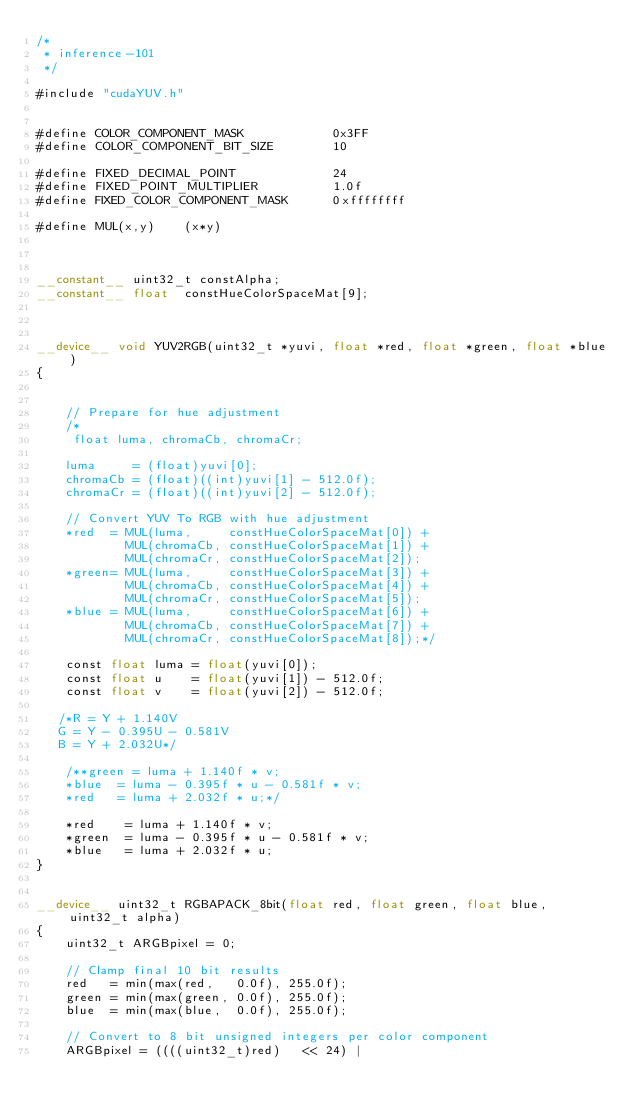<code> <loc_0><loc_0><loc_500><loc_500><_Cuda_>/*
 * inference-101
 */

#include "cudaYUV.h"


#define COLOR_COMPONENT_MASK            0x3FF
#define COLOR_COMPONENT_BIT_SIZE        10

#define FIXED_DECIMAL_POINT             24
#define FIXED_POINT_MULTIPLIER          1.0f
#define FIXED_COLOR_COMPONENT_MASK      0xffffffff

#define MUL(x,y)    (x*y)



__constant__ uint32_t constAlpha;
__constant__ float  constHueColorSpaceMat[9];



__device__ void YUV2RGB(uint32_t *yuvi, float *red, float *green, float *blue)
{
   

    // Prepare for hue adjustment
    /*
	 float luma, chromaCb, chromaCr;

	luma     = (float)yuvi[0];
    chromaCb = (float)((int)yuvi[1] - 512.0f);
    chromaCr = (float)((int)yuvi[2] - 512.0f);

    // Convert YUV To RGB with hue adjustment
    *red  = MUL(luma,     constHueColorSpaceMat[0]) +
            MUL(chromaCb, constHueColorSpaceMat[1]) +
            MUL(chromaCr, constHueColorSpaceMat[2]);
    *green= MUL(luma,     constHueColorSpaceMat[3]) +
            MUL(chromaCb, constHueColorSpaceMat[4]) +
            MUL(chromaCr, constHueColorSpaceMat[5]);
    *blue = MUL(luma,     constHueColorSpaceMat[6]) +
            MUL(chromaCb, constHueColorSpaceMat[7]) +
            MUL(chromaCr, constHueColorSpaceMat[8]);*/

	const float luma = float(yuvi[0]);
	const float u    = float(yuvi[1]) - 512.0f;
	const float v    = float(yuvi[2]) - 512.0f;

   /*R = Y + 1.140V
   G = Y - 0.395U - 0.581V
   B = Y + 2.032U*/

	/**green = luma + 1.140f * v;
	*blue  = luma - 0.395f * u - 0.581f * v;
	*red   = luma + 2.032f * u;*/

	*red    = luma + 1.140f * v;
	*green  = luma - 0.395f * u - 0.581f * v;
	*blue   = luma + 2.032f * u;
}


__device__ uint32_t RGBAPACK_8bit(float red, float green, float blue, uint32_t alpha)
{
    uint32_t ARGBpixel = 0;

    // Clamp final 10 bit results
    red   = min(max(red,   0.0f), 255.0f);
    green = min(max(green, 0.0f), 255.0f);
    blue  = min(max(blue,  0.0f), 255.0f);

    // Convert to 8 bit unsigned integers per color component
    ARGBpixel = ((((uint32_t)red)   << 24) |</code> 